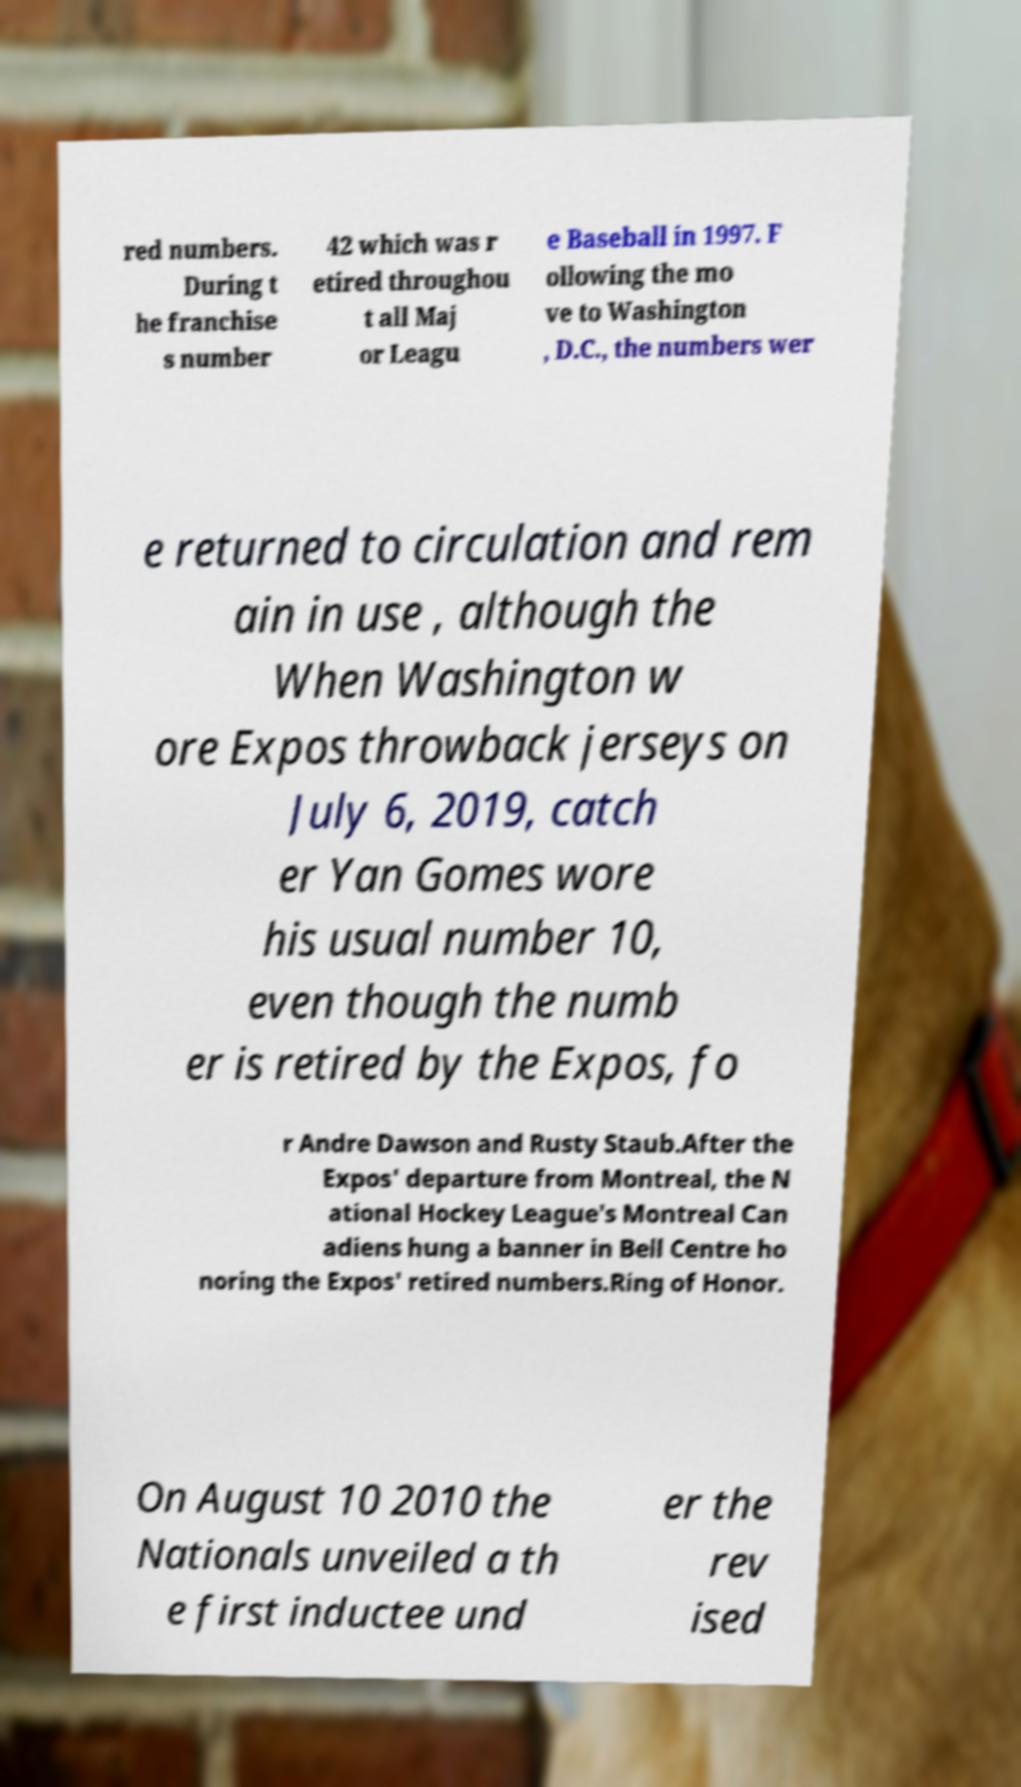There's text embedded in this image that I need extracted. Can you transcribe it verbatim? red numbers. During t he franchise s number 42 which was r etired throughou t all Maj or Leagu e Baseball in 1997. F ollowing the mo ve to Washington , D.C., the numbers wer e returned to circulation and rem ain in use , although the When Washington w ore Expos throwback jerseys on July 6, 2019, catch er Yan Gomes wore his usual number 10, even though the numb er is retired by the Expos, fo r Andre Dawson and Rusty Staub.After the Expos' departure from Montreal, the N ational Hockey League′s Montreal Can adiens hung a banner in Bell Centre ho noring the Expos' retired numbers.Ring of Honor. On August 10 2010 the Nationals unveiled a th e first inductee und er the rev ised 